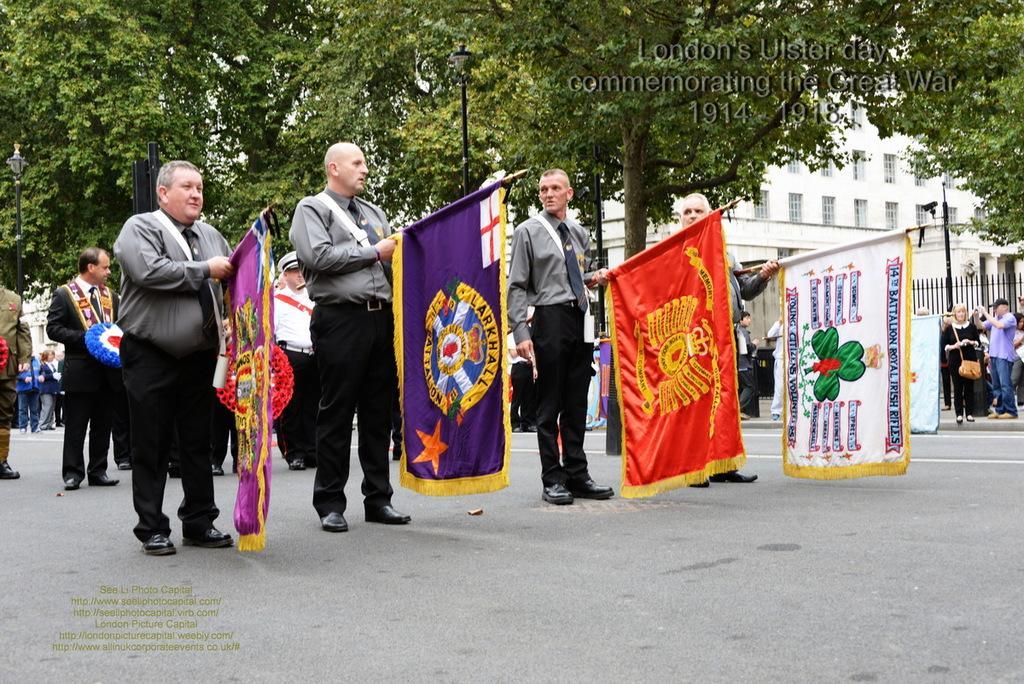Describe this image in one or two sentences. In the image we can see there are people standing, wearing clothes, shoes and they are holding a flag in their hands. Here we can see road, light poles and building. Here we can see the fence and watermarks. 